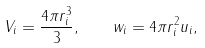Convert formula to latex. <formula><loc_0><loc_0><loc_500><loc_500>V _ { i } = \frac { 4 \pi r _ { i } ^ { 3 } } { 3 } , \quad w _ { i } = 4 \pi r ^ { 2 } _ { i } u _ { i } ,</formula> 